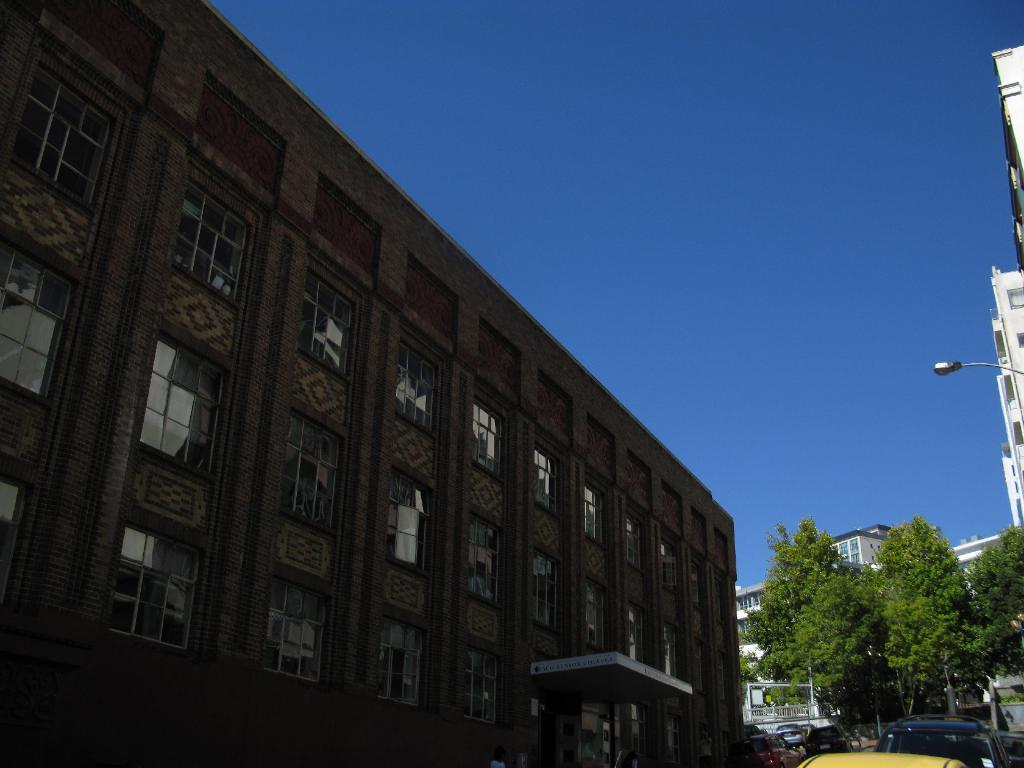What type of structures can be seen in the image? There are buildings in the image. What other natural elements are present in the image? There are trees in the image. What kind of barrier can be seen in the image? There is a fence in the image. What mode of transportation is visible in the image? There are fleets of vehicles on the road in the image. What is the color of the sky in the image? The sky is blue and visible at the top of the image. From where do you think the image was taken? The image appears to be taken from a roadside perspective. Can you see any icicles hanging from the buildings in the image? There are no icicles visible in the image. What type of paper is being used by the trees in the image? There is no paper present in the image; it features buildings, trees, a fence, vehicles, and a blue sky. 